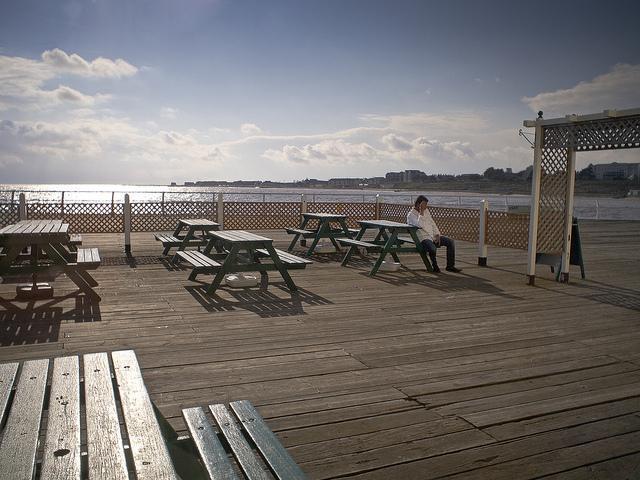How many empty picnic tables?
Give a very brief answer. 6. How many narrow beams make up one bench?
Give a very brief answer. 3. How many benches are occupied?
Give a very brief answer. 1. How many benches can you see?
Give a very brief answer. 3. How many sandwiches are on the plate with tongs?
Give a very brief answer. 0. 